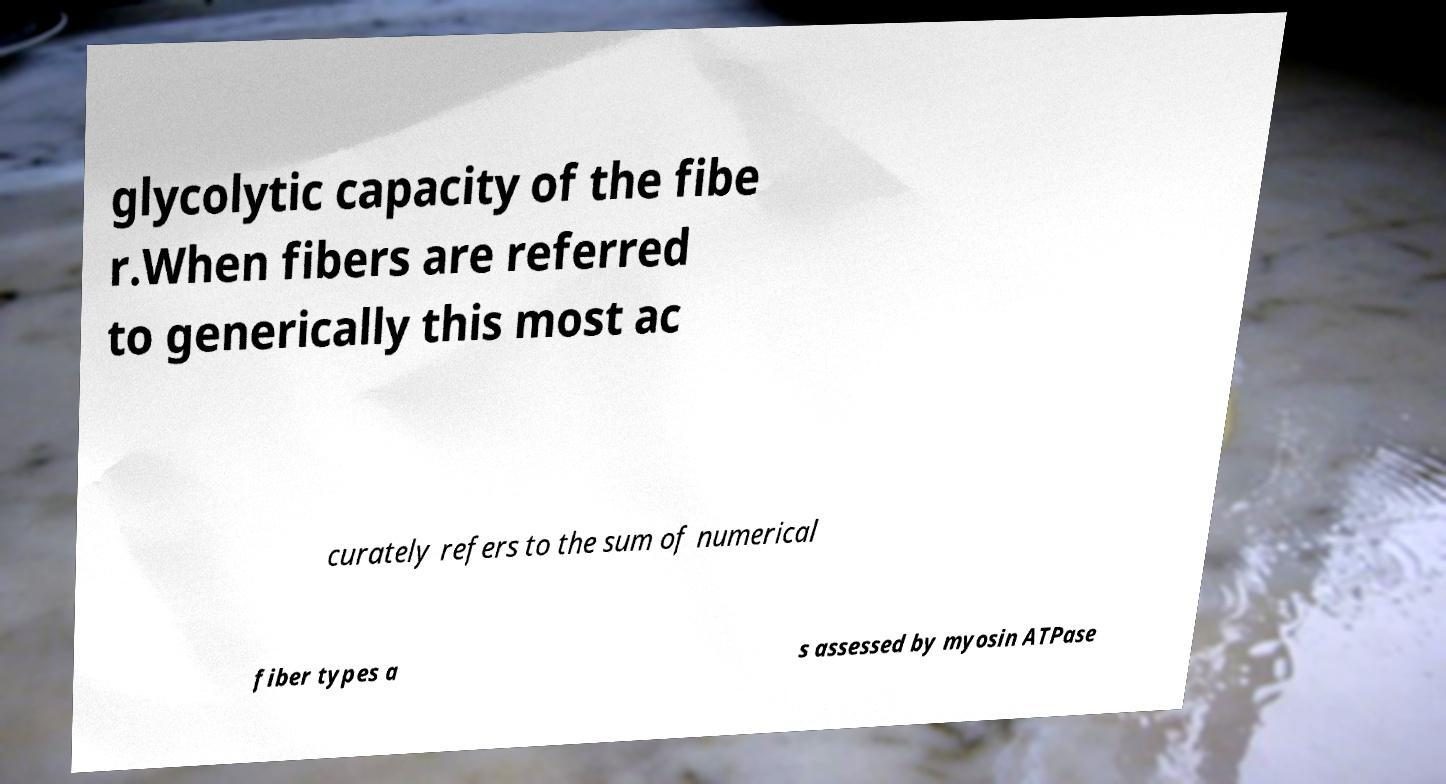Please identify and transcribe the text found in this image. glycolytic capacity of the fibe r.When fibers are referred to generically this most ac curately refers to the sum of numerical fiber types a s assessed by myosin ATPase 